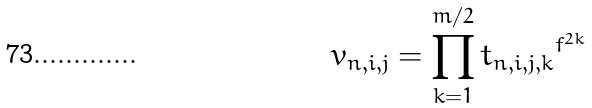Convert formula to latex. <formula><loc_0><loc_0><loc_500><loc_500>v _ { n , i , j } = \prod _ { k = 1 } ^ { m / 2 } { t _ { n , i , j , k } } ^ { f ^ { 2 k } }</formula> 